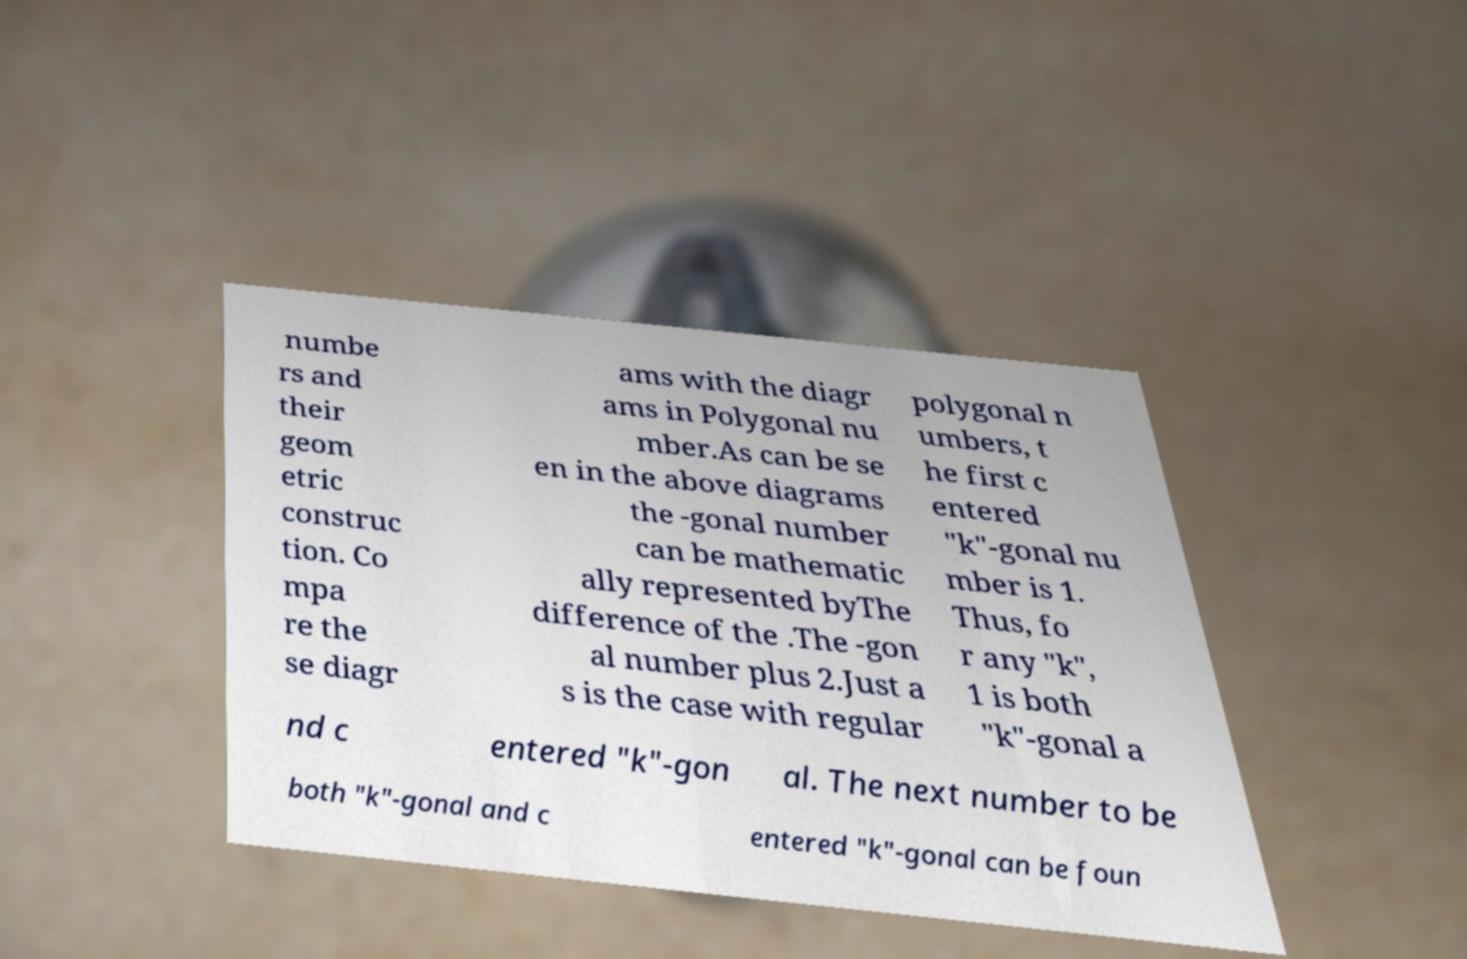For documentation purposes, I need the text within this image transcribed. Could you provide that? numbe rs and their geom etric construc tion. Co mpa re the se diagr ams with the diagr ams in Polygonal nu mber.As can be se en in the above diagrams the -gonal number can be mathematic ally represented byThe difference of the .The -gon al number plus 2.Just a s is the case with regular polygonal n umbers, t he first c entered "k"-gonal nu mber is 1. Thus, fo r any "k", 1 is both "k"-gonal a nd c entered "k"-gon al. The next number to be both "k"-gonal and c entered "k"-gonal can be foun 